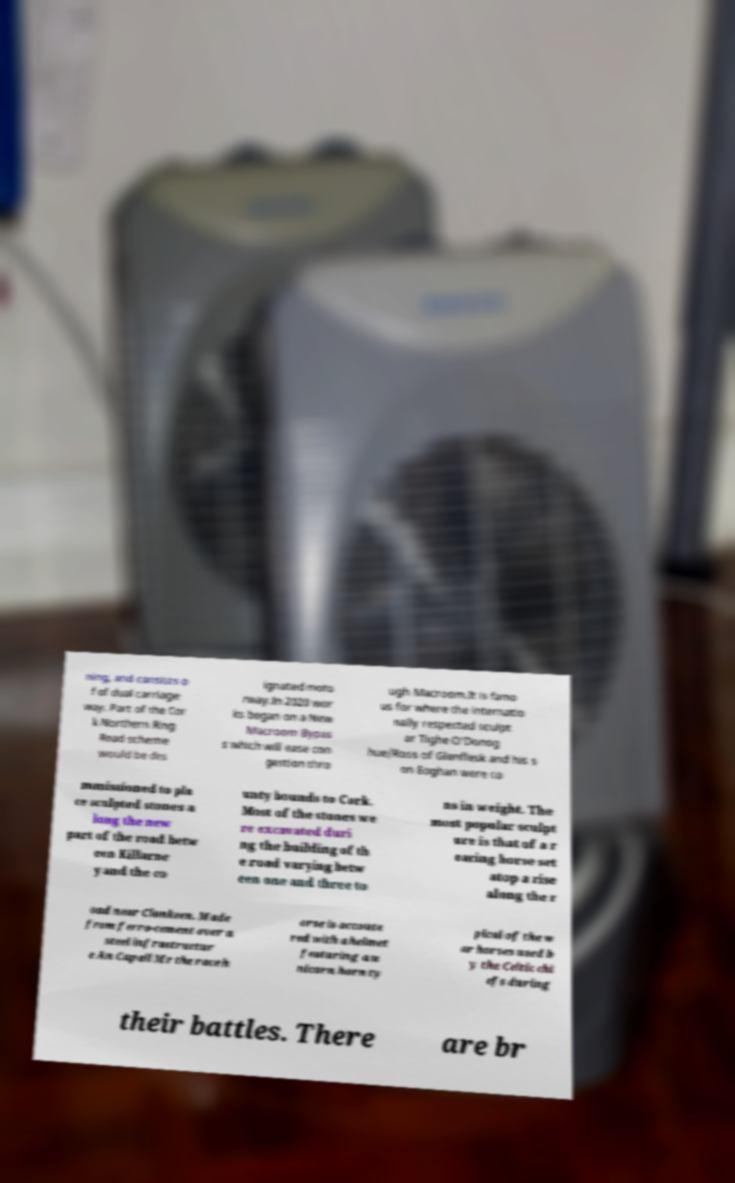Please read and relay the text visible in this image. What does it say? ning, and consists o f of dual carriage way. Part of the Cor k Northern Ring Road scheme would be des ignated moto rway.In 2020 wor ks began on a New Macroom Bypas s which will ease con gestion thro ugh Macroom.It is famo us for where the internatio nally respected sculpt or Tighe O'Donog hue/Ross of Glenflesk and his s on Eoghan were co mmissioned to pla ce sculpted stones a long the new part of the road betw een Killarne y and the co unty bounds to Cork. Most of the stones we re excavated duri ng the building of th e road varying betw een one and three to ns in weight. The most popular sculpt ure is that of a r earing horse set atop a rise along the r oad near Clonkeen. Made from ferro-cement over a steel infrastructur e An Capall Mr the race h orse is accoute red with a helmet featuring a u nicorn horn ty pical of the w ar horses used b y the Celtic chi efs during their battles. There are br 